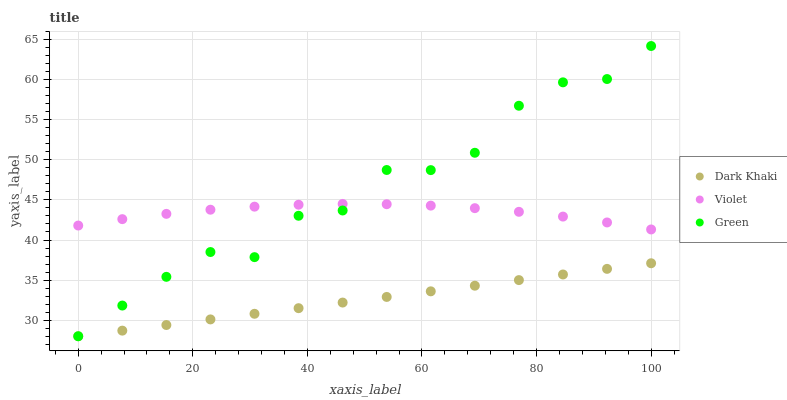Does Dark Khaki have the minimum area under the curve?
Answer yes or no. Yes. Does Green have the maximum area under the curve?
Answer yes or no. Yes. Does Violet have the minimum area under the curve?
Answer yes or no. No. Does Violet have the maximum area under the curve?
Answer yes or no. No. Is Dark Khaki the smoothest?
Answer yes or no. Yes. Is Green the roughest?
Answer yes or no. Yes. Is Violet the smoothest?
Answer yes or no. No. Is Violet the roughest?
Answer yes or no. No. Does Dark Khaki have the lowest value?
Answer yes or no. Yes. Does Violet have the lowest value?
Answer yes or no. No. Does Green have the highest value?
Answer yes or no. Yes. Does Violet have the highest value?
Answer yes or no. No. Is Dark Khaki less than Violet?
Answer yes or no. Yes. Is Violet greater than Dark Khaki?
Answer yes or no. Yes. Does Violet intersect Green?
Answer yes or no. Yes. Is Violet less than Green?
Answer yes or no. No. Is Violet greater than Green?
Answer yes or no. No. Does Dark Khaki intersect Violet?
Answer yes or no. No. 